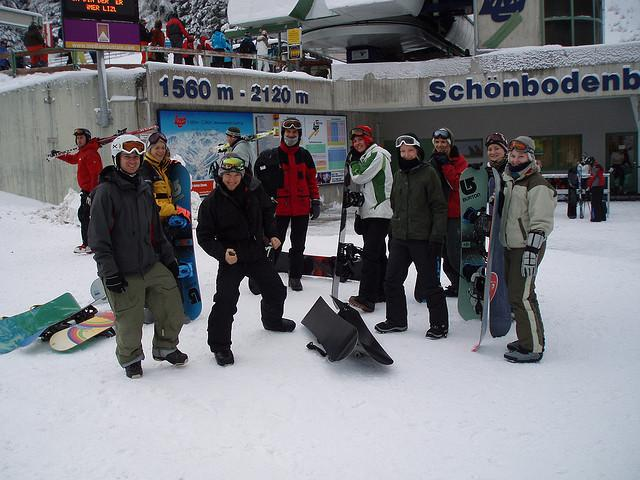This photo was taken in front of what kind of attraction? ski lodge 